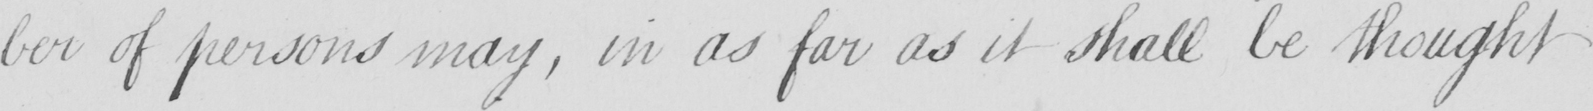Please transcribe the handwritten text in this image. -ber of persons may , in as far as it shall be thought 